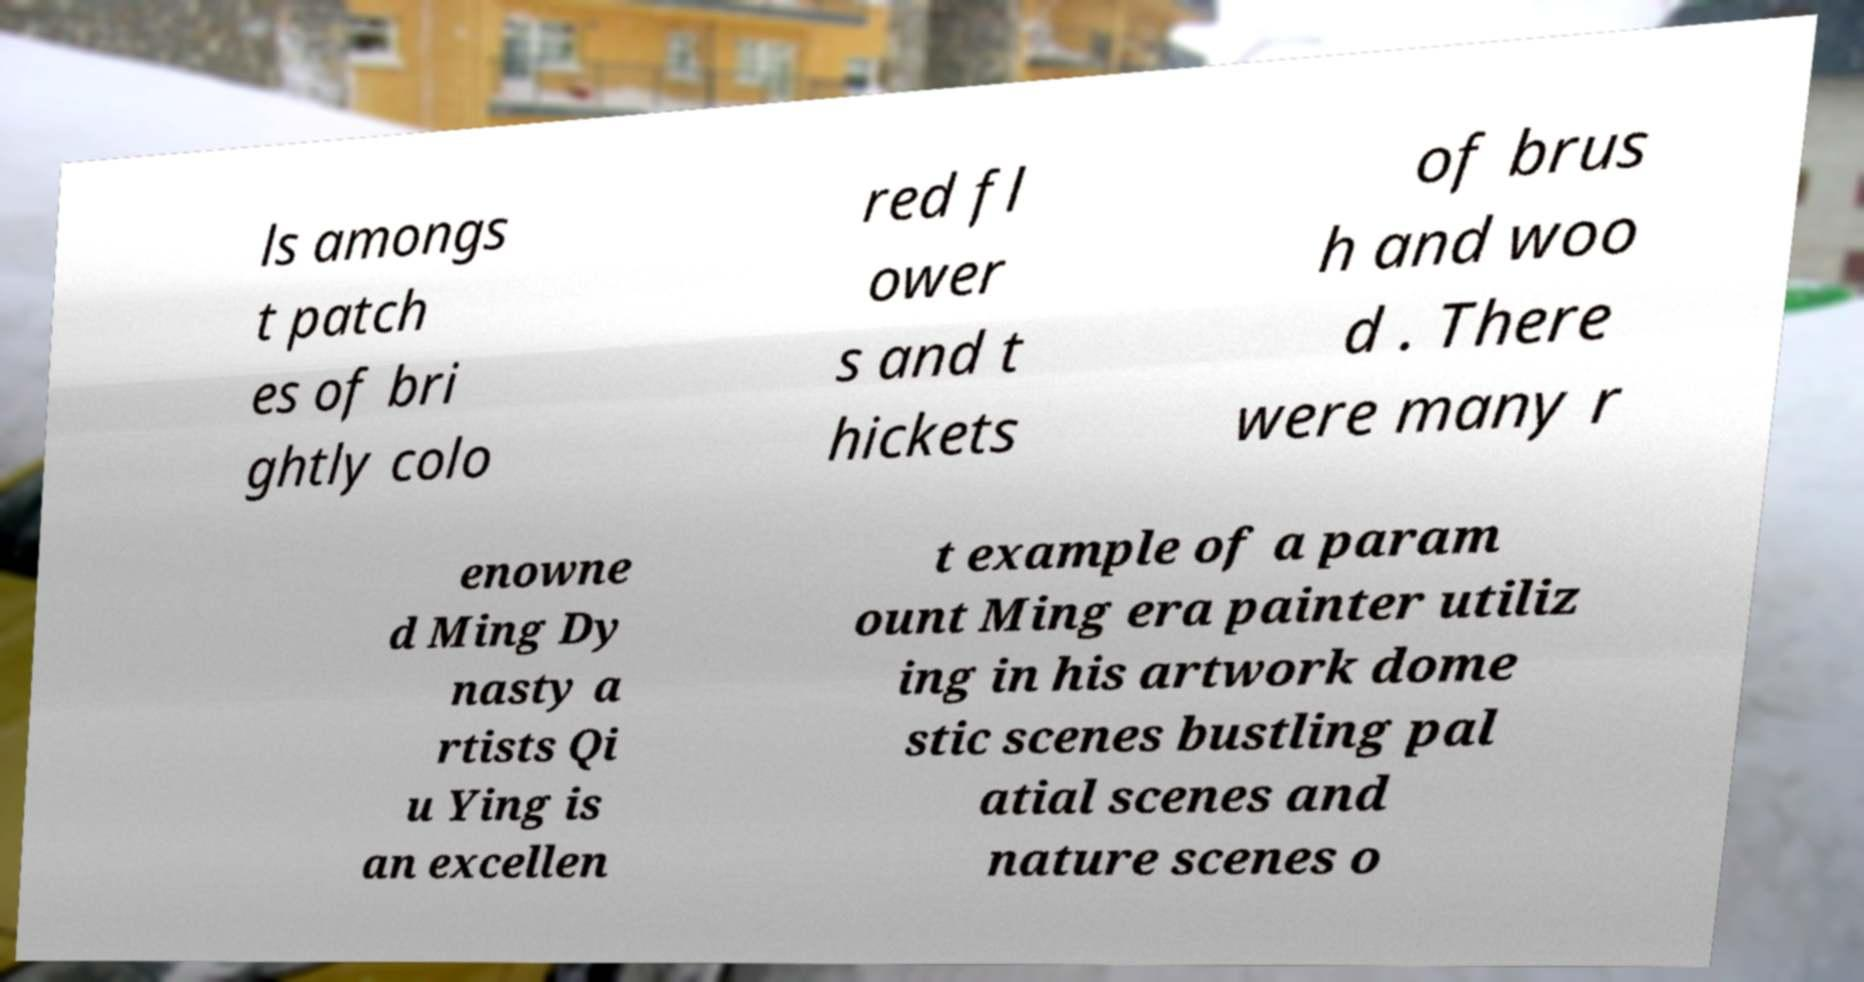Please identify and transcribe the text found in this image. ls amongs t patch es of bri ghtly colo red fl ower s and t hickets of brus h and woo d . There were many r enowne d Ming Dy nasty a rtists Qi u Ying is an excellen t example of a param ount Ming era painter utiliz ing in his artwork dome stic scenes bustling pal atial scenes and nature scenes o 